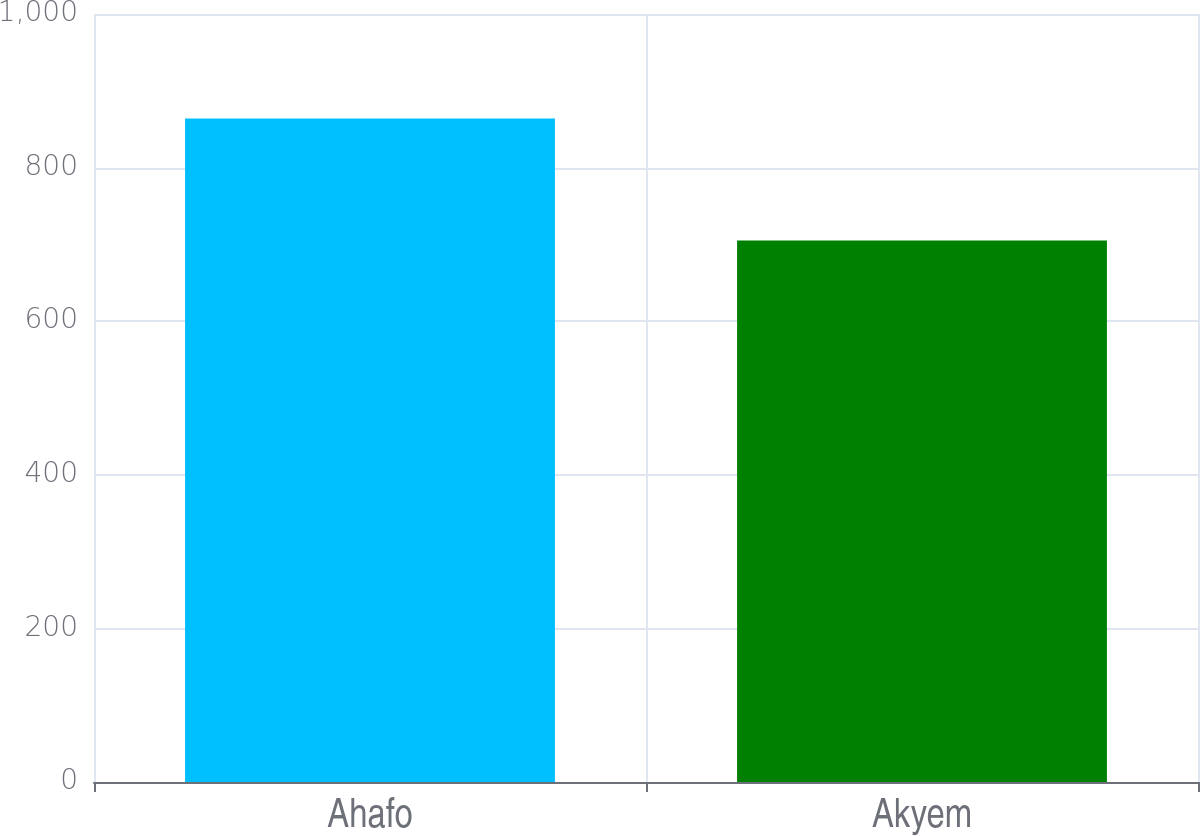<chart> <loc_0><loc_0><loc_500><loc_500><bar_chart><fcel>Ahafo<fcel>Akyem<nl><fcel>864<fcel>705<nl></chart> 